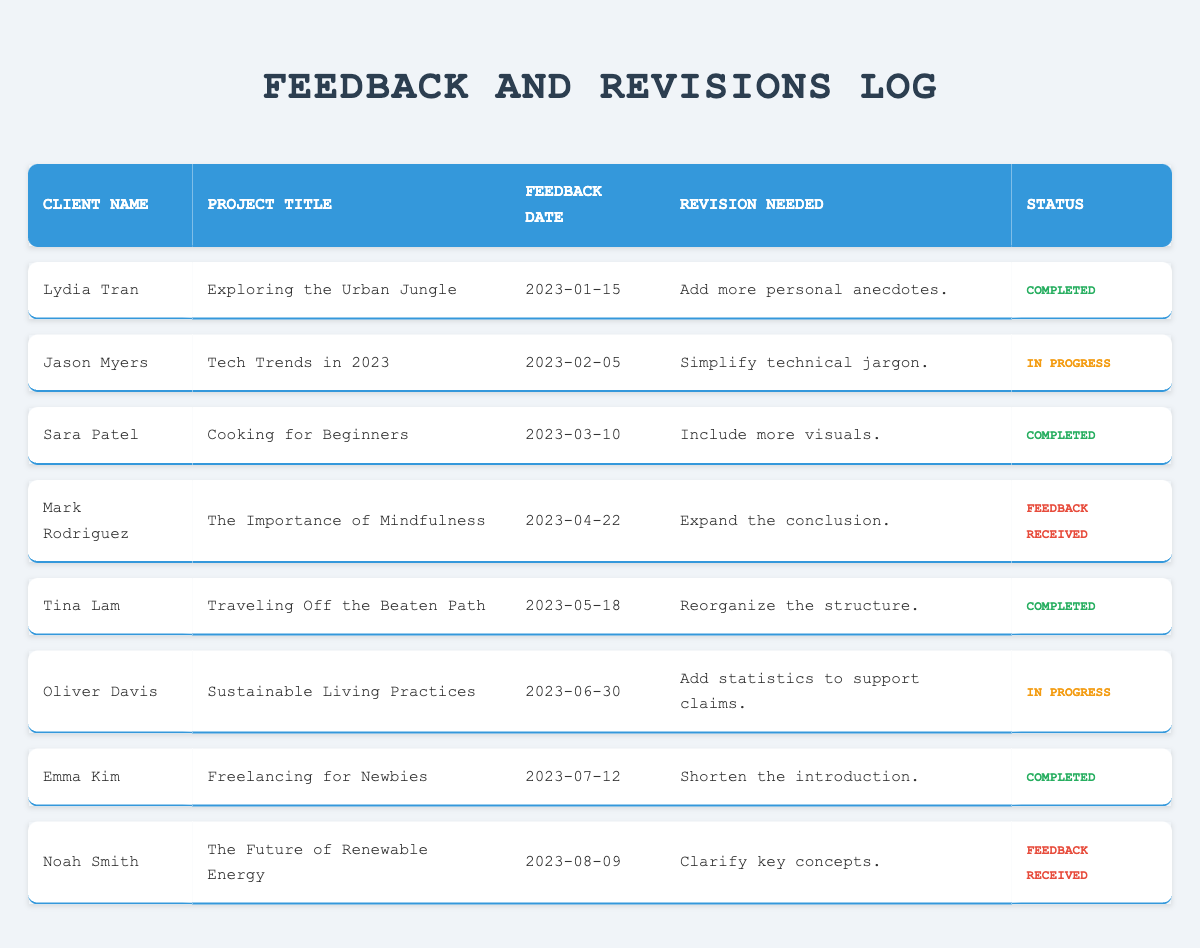What is the status of the project titled "Tech Trends in 2023"? The project titled "Tech Trends in 2023" is associated with Jason Myers, and under the status column, it shows "In Progress."
Answer: In Progress How many projects have been marked as "Completed"? By counting the "Completed" status in the status column, we find that there are 4 completed projects: "Exploring the Urban Jungle," "Cooking for Beginners," "Traveling Off the Beaten Path," and "Freelancing for Newbies."
Answer: 4 Which client requested to expand the conclusion? The project titled "The Importance of Mindfulness" is associated with Mark Rodriguez, who requested to expand the conclusion, as noted in the revision column and under the feedback received status.
Answer: Mark Rodriguez Did any projects receive feedback on the same date? Yes, the feedback for both "The Importance of Mindfulness" and "The Future of Renewable Energy" was received on the same date, which indicates that feedback was provided on 2023-08-09.
Answer: Yes What is the average number of revisions needed for completed projects? There are 4 completed projects: "Exploring the Urban Jungle," "Cooking for Beginners," "Traveling Off the Beaten Path," and "Freelancing for Newbies," each with one revision needed, giving a total of 4 revisions. The average number of revisions is thus 4/4, which equals 1.
Answer: 1 Which project has the latest feedback date? The project titled "The Future of Renewable Energy" has the latest feedback date recorded in the table, which is 2023-08-09, making it the most recent entry.
Answer: The Future of Renewable Energy How many clients were involved in projects that are still "In Progress"? The projects that are "In Progress" involve 2 clients: Jason Myers for "Tech Trends in 2023" and Oliver Davis for "Sustainable Living Practices."
Answer: 2 Is there a project that requires adding statistics to support claims? Yes, the project titled "Sustainable Living Practices" needs the addition of statistics to support claims, as stated in the revision required column.
Answer: Yes 